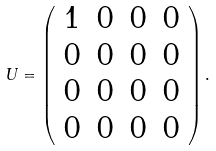Convert formula to latex. <formula><loc_0><loc_0><loc_500><loc_500>U = \left ( \begin{array} { c c c c } 1 & 0 & 0 & 0 \\ 0 & 0 & 0 & 0 \\ 0 & 0 & 0 & 0 \\ 0 & 0 & 0 & 0 \end{array} \right ) .</formula> 